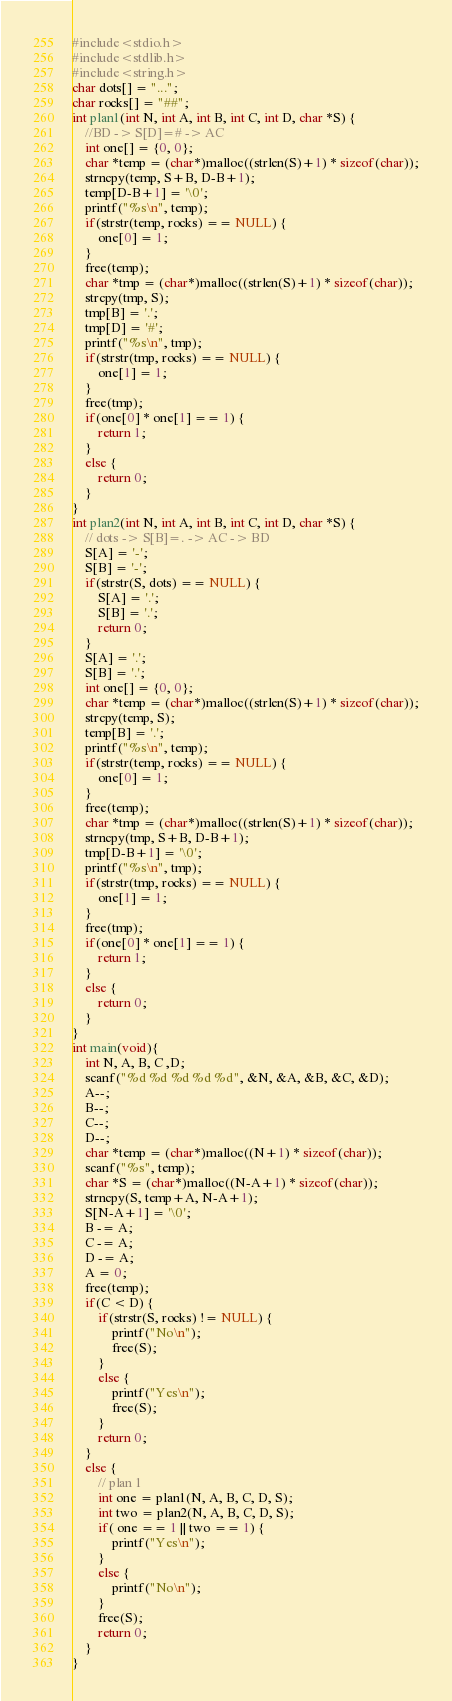<code> <loc_0><loc_0><loc_500><loc_500><_C_>#include<stdio.h>
#include<stdlib.h>
#include<string.h>
char dots[] = "...";
char rocks[] = "##";
int plan1(int N, int A, int B, int C, int D, char *S) {
    //BD -> S[D]=# -> AC
    int one[] = {0, 0};
    char *temp = (char*)malloc((strlen(S)+1) * sizeof(char));
    strncpy(temp, S+B, D-B+1);
    temp[D-B+1] = '\0';
    printf("%s\n", temp);
    if(strstr(temp, rocks) == NULL) {
        one[0] = 1;
    }
    free(temp);
    char *tmp = (char*)malloc((strlen(S)+1) * sizeof(char));
    strcpy(tmp, S);
    tmp[B] = '.';
    tmp[D] = '#';
    printf("%s\n", tmp);
    if(strstr(tmp, rocks) == NULL) {
        one[1] = 1;
    }
    free(tmp);
    if(one[0] * one[1] == 1) {
        return 1;
    }
    else {
        return 0;
    }
}
int plan2(int N, int A, int B, int C, int D, char *S) {
    // dots -> S[B]=. -> AC -> BD
    S[A] = '-';
    S[B] = '-';
    if(strstr(S, dots) == NULL) {
        S[A] = '.';
        S[B] = '.';
        return 0;
    }
    S[A] = '.';
    S[B] = '.';
    int one[] = {0, 0};
    char *temp = (char*)malloc((strlen(S)+1) * sizeof(char));
    strcpy(temp, S);
    temp[B] = '.';
    printf("%s\n", temp);
    if(strstr(temp, rocks) == NULL) {
        one[0] = 1;
    }
    free(temp);
    char *tmp = (char*)malloc((strlen(S)+1) * sizeof(char));
    strncpy(tmp, S+B, D-B+1);
    tmp[D-B+1] = '\0';
    printf("%s\n", tmp);
    if(strstr(tmp, rocks) == NULL) {
        one[1] = 1;
    }
    free(tmp);
    if(one[0] * one[1] == 1) {
        return 1;
    }
    else {
        return 0;
    }
}
int main(void){
    int N, A, B, C ,D;
    scanf("%d %d %d %d %d", &N, &A, &B, &C, &D);
    A--;
    B--;
    C--;
    D--;
    char *temp = (char*)malloc((N+1) * sizeof(char));
    scanf("%s", temp);
    char *S = (char*)malloc((N-A+1) * sizeof(char));
    strncpy(S, temp+A, N-A+1);
    S[N-A+1] = '\0';
    B -= A;
    C -= A;
    D -= A;
    A = 0;
    free(temp);
    if(C < D) {
        if(strstr(S, rocks) != NULL) {
            printf("No\n");
            free(S);
        }
        else {
            printf("Yes\n");
            free(S);
        }
        return 0;
    }
    else {
        // plan 1
        int one = plan1(N, A, B, C, D, S);
        int two = plan2(N, A, B, C, D, S);
        if( one == 1 || two == 1) {
            printf("Yes\n");
        }
        else {
            printf("No\n");
        }
        free(S);
        return 0;
    }
}</code> 